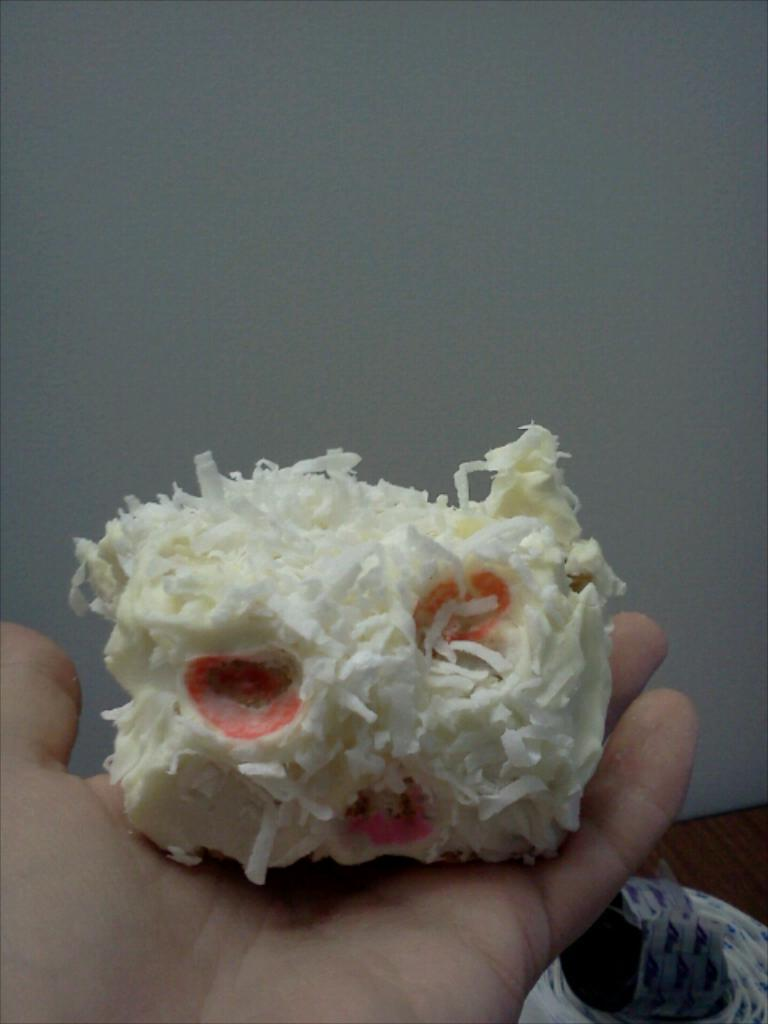What is being held in the human hand in the image? There is a food item in a human hand in the image. What can be seen in the background of the image? There is a white color wall in the background of the image. Can you describe the object located in the right bottom of the image? There is an object in the right bottom of the image, but its specific details are not mentioned in the provided facts. What type of bomb is being detonated in the image? There is no bomb present in the image; it features a food item in a human hand and a white color wall in the background. 